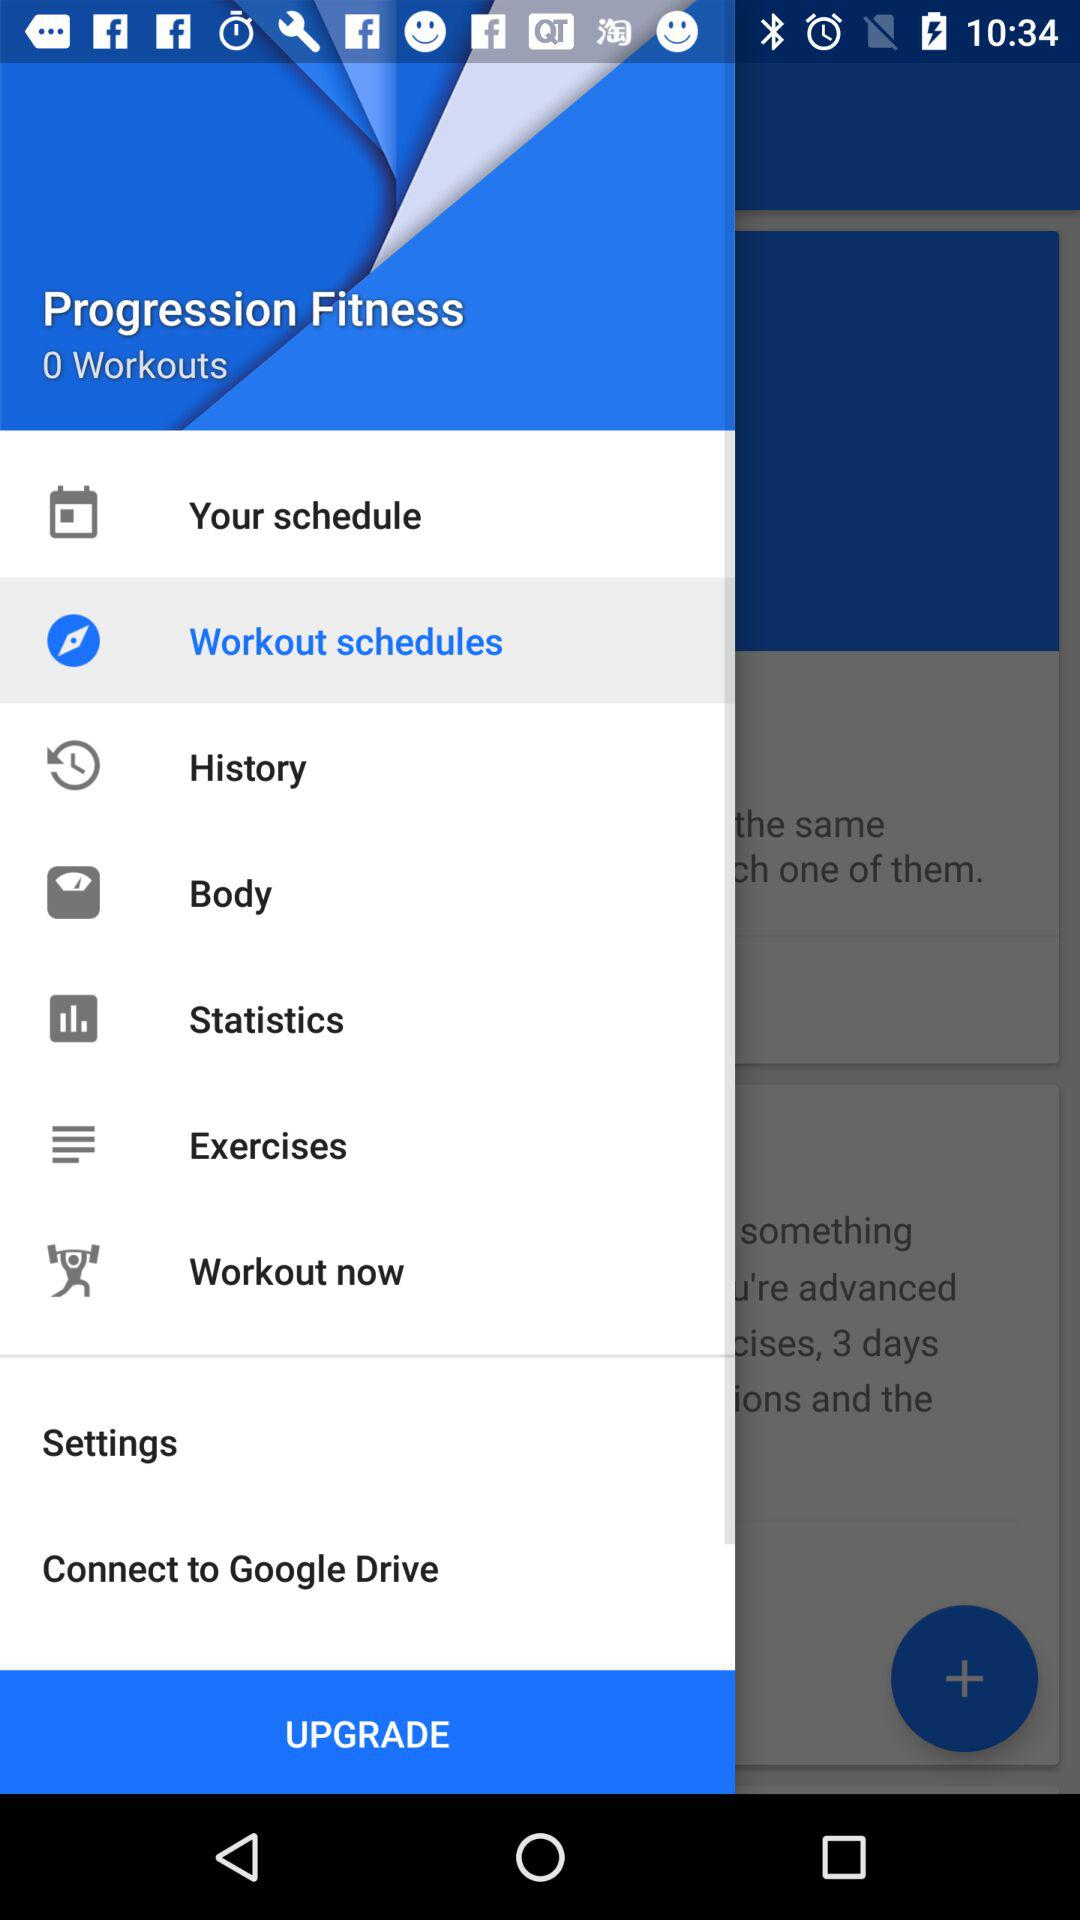Which option has been selected? The selected option is "Workout schedules". 